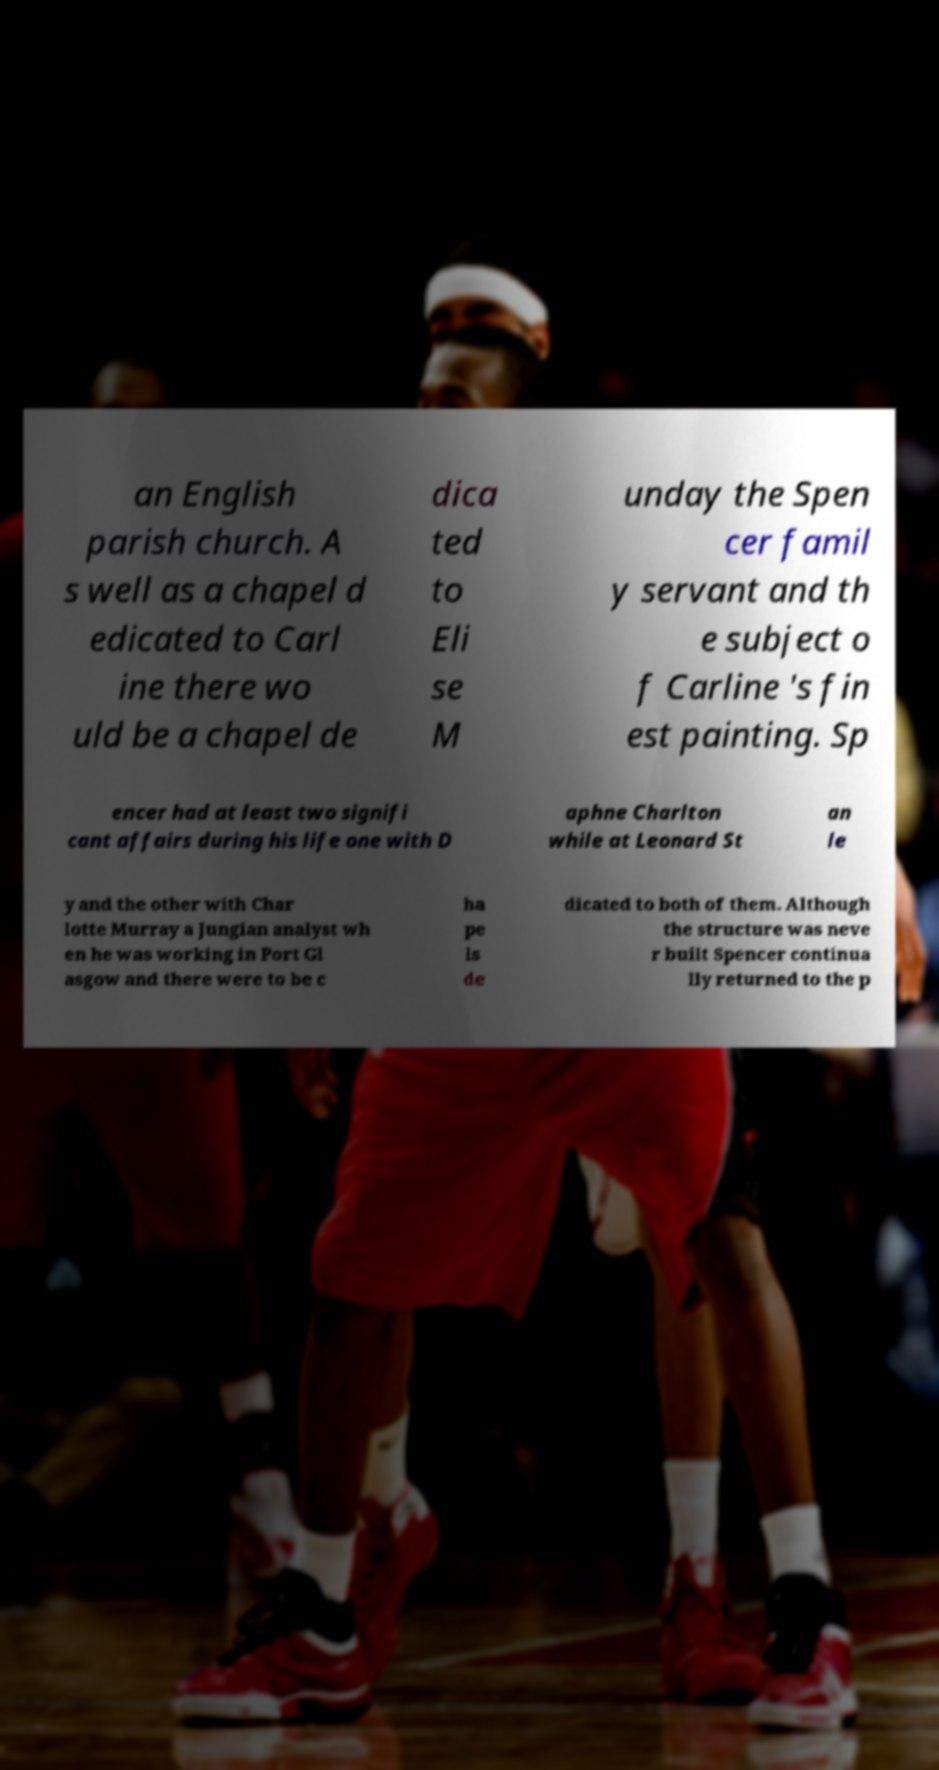Could you extract and type out the text from this image? an English parish church. A s well as a chapel d edicated to Carl ine there wo uld be a chapel de dica ted to Eli se M unday the Spen cer famil y servant and th e subject o f Carline 's fin est painting. Sp encer had at least two signifi cant affairs during his life one with D aphne Charlton while at Leonard St an le y and the other with Char lotte Murray a Jungian analyst wh en he was working in Port Gl asgow and there were to be c ha pe ls de dicated to both of them. Although the structure was neve r built Spencer continua lly returned to the p 